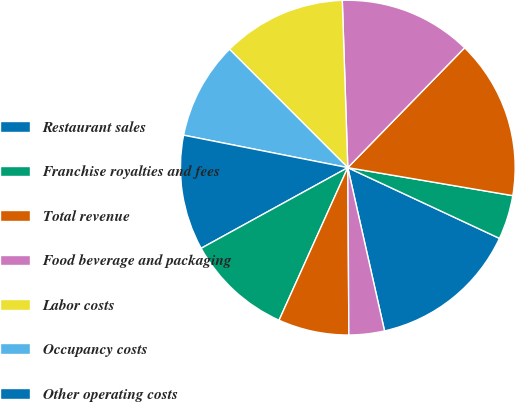Convert chart. <chart><loc_0><loc_0><loc_500><loc_500><pie_chart><fcel>Restaurant sales<fcel>Franchise royalties and fees<fcel>Total revenue<fcel>Food beverage and packaging<fcel>Labor costs<fcel>Occupancy costs<fcel>Other operating costs<fcel>General and administrative<fcel>Depreciation and amortization<fcel>Pre-opening costs<nl><fcel>14.53%<fcel>4.27%<fcel>15.38%<fcel>12.82%<fcel>11.97%<fcel>9.4%<fcel>11.11%<fcel>10.26%<fcel>6.84%<fcel>3.42%<nl></chart> 